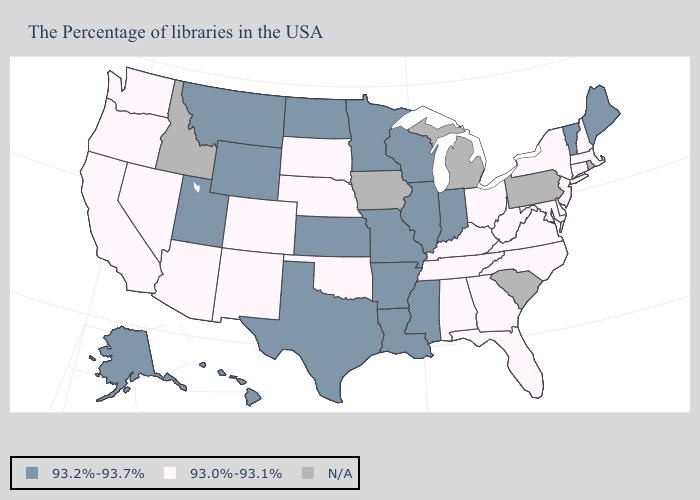Does the first symbol in the legend represent the smallest category?
Short answer required. No. Is the legend a continuous bar?
Keep it brief. No. Name the states that have a value in the range N/A?
Answer briefly. Rhode Island, Pennsylvania, South Carolina, Michigan, Iowa, Idaho. Does North Dakota have the highest value in the USA?
Give a very brief answer. Yes. Is the legend a continuous bar?
Quick response, please. No. Name the states that have a value in the range N/A?
Give a very brief answer. Rhode Island, Pennsylvania, South Carolina, Michigan, Iowa, Idaho. Among the states that border Utah , does Nevada have the lowest value?
Concise answer only. Yes. Which states have the highest value in the USA?
Give a very brief answer. Maine, Vermont, Indiana, Wisconsin, Illinois, Mississippi, Louisiana, Missouri, Arkansas, Minnesota, Kansas, Texas, North Dakota, Wyoming, Utah, Montana, Alaska, Hawaii. What is the value of Oklahoma?
Give a very brief answer. 93.0%-93.1%. What is the value of New Jersey?
Give a very brief answer. 93.0%-93.1%. Which states have the lowest value in the USA?
Write a very short answer. Massachusetts, New Hampshire, Connecticut, New York, New Jersey, Delaware, Maryland, Virginia, North Carolina, West Virginia, Ohio, Florida, Georgia, Kentucky, Alabama, Tennessee, Nebraska, Oklahoma, South Dakota, Colorado, New Mexico, Arizona, Nevada, California, Washington, Oregon. Is the legend a continuous bar?
Answer briefly. No. Which states have the lowest value in the MidWest?
Quick response, please. Ohio, Nebraska, South Dakota. What is the value of North Dakota?
Be succinct. 93.2%-93.7%. 